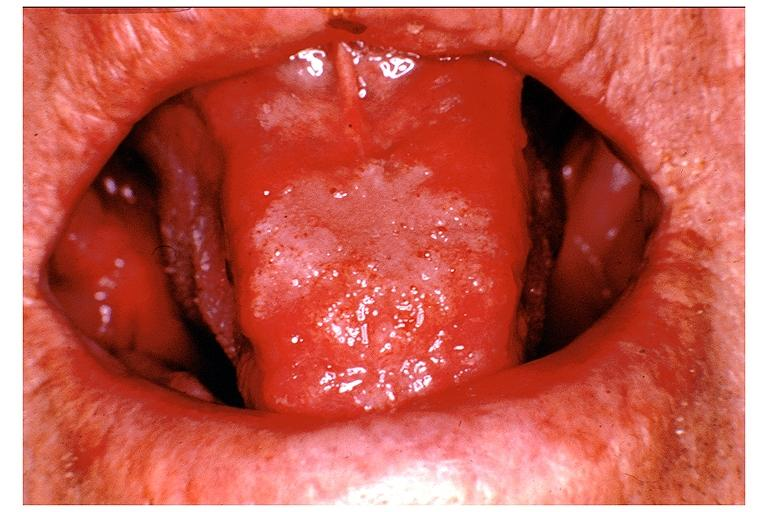what does this image show?
Answer the question using a single word or phrase. Blastomycosis 